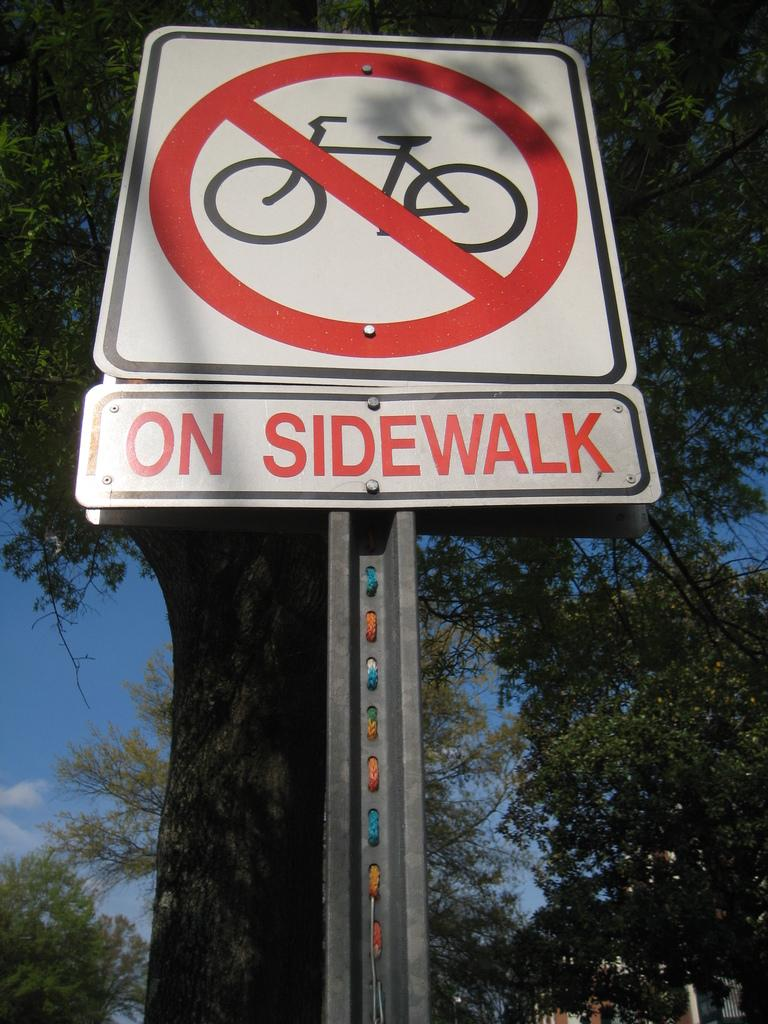Provide a one-sentence caption for the provided image. A sign shows no bikes allowed on the sidewalk. 